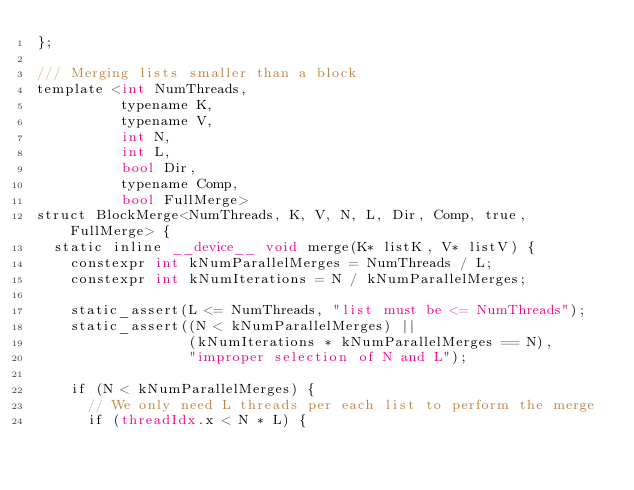<code> <loc_0><loc_0><loc_500><loc_500><_Cuda_>};

/// Merging lists smaller than a block
template <int NumThreads,
          typename K,
          typename V,
          int N,
          int L,
          bool Dir,
          typename Comp,
          bool FullMerge>
struct BlockMerge<NumThreads, K, V, N, L, Dir, Comp, true, FullMerge> {
  static inline __device__ void merge(K* listK, V* listV) {
    constexpr int kNumParallelMerges = NumThreads / L;
    constexpr int kNumIterations = N / kNumParallelMerges;

    static_assert(L <= NumThreads, "list must be <= NumThreads");
    static_assert((N < kNumParallelMerges) ||
                  (kNumIterations * kNumParallelMerges == N),
                  "improper selection of N and L");

    if (N < kNumParallelMerges) {
      // We only need L threads per each list to perform the merge
      if (threadIdx.x < N * L) {</code> 